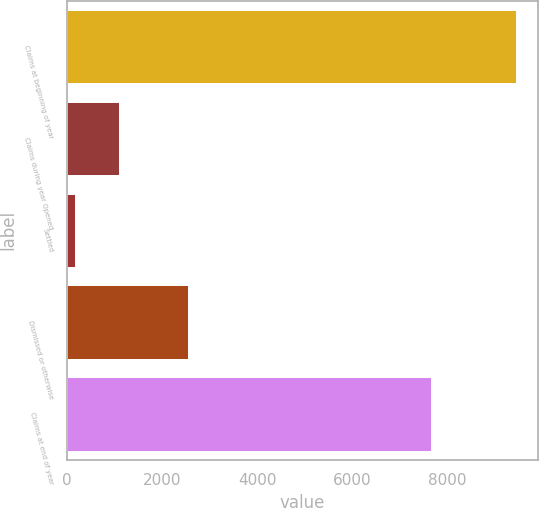Convert chart to OTSL. <chart><loc_0><loc_0><loc_500><loc_500><bar_chart><fcel>Claims at beginning of year<fcel>Claims during year Opened<fcel>Settled<fcel>Dismissed or otherwise<fcel>Claims at end of year<nl><fcel>9442<fcel>1105.3<fcel>179<fcel>2548<fcel>7652<nl></chart> 